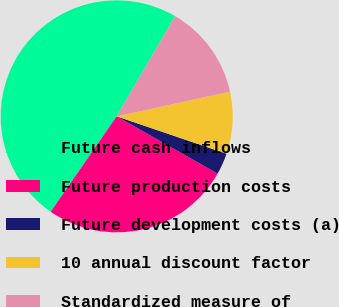<chart> <loc_0><loc_0><loc_500><loc_500><pie_chart><fcel>Future cash inflows<fcel>Future production costs<fcel>Future development costs (a)<fcel>10 annual discount factor<fcel>Standardized measure of<nl><fcel>48.76%<fcel>26.41%<fcel>3.0%<fcel>8.63%<fcel>13.2%<nl></chart> 